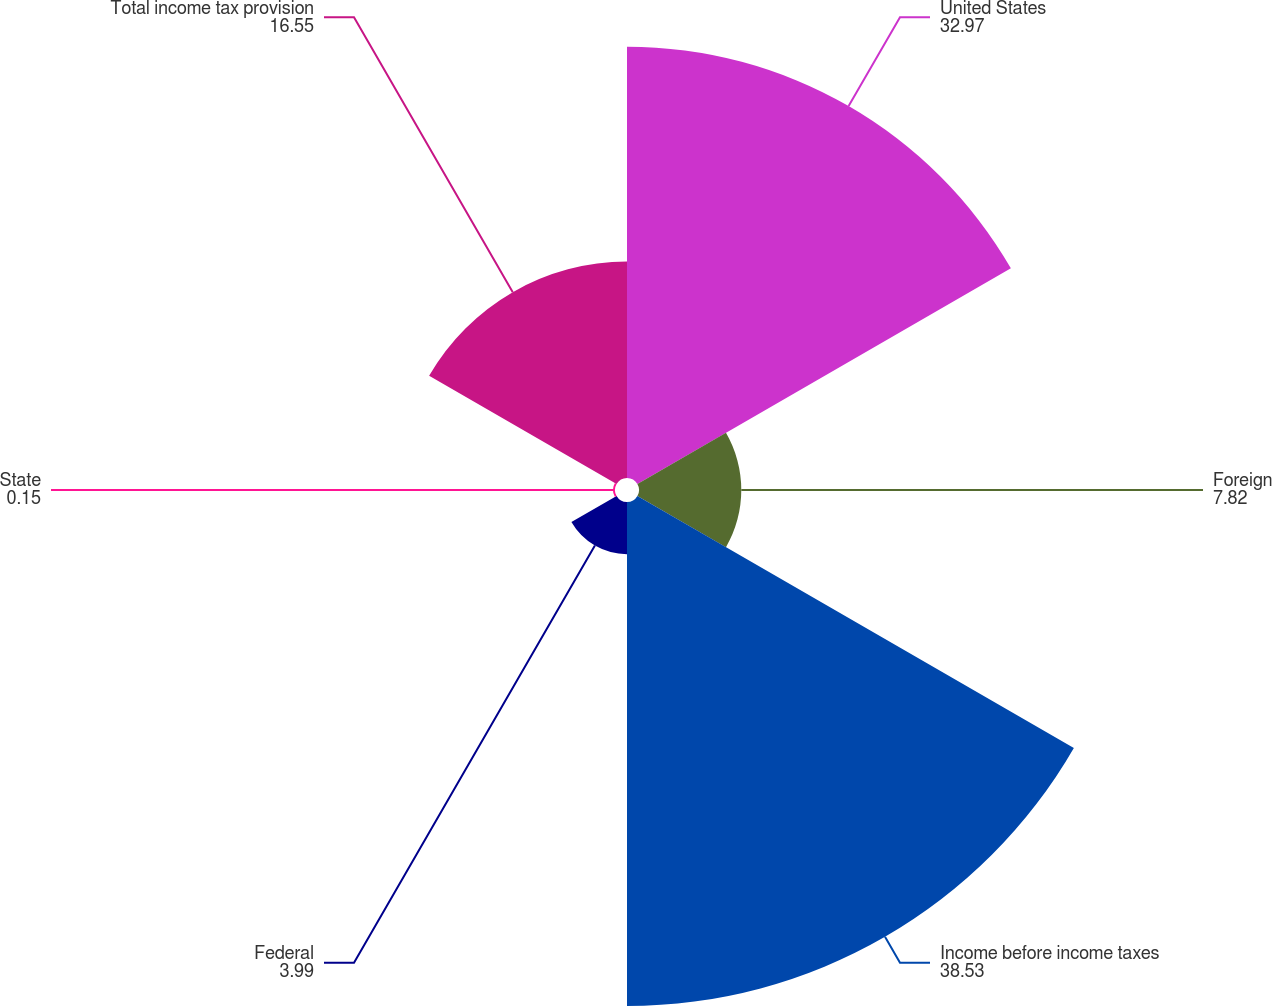Convert chart. <chart><loc_0><loc_0><loc_500><loc_500><pie_chart><fcel>United States<fcel>Foreign<fcel>Income before income taxes<fcel>Federal<fcel>State<fcel>Total income tax provision<nl><fcel>32.97%<fcel>7.82%<fcel>38.53%<fcel>3.99%<fcel>0.15%<fcel>16.55%<nl></chart> 